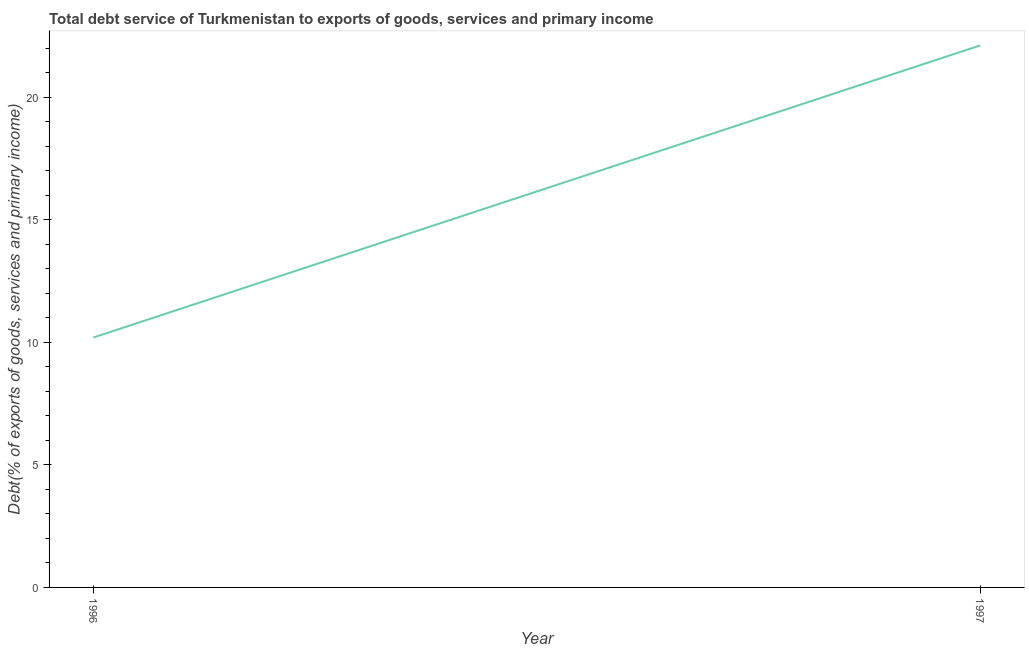What is the total debt service in 1997?
Give a very brief answer. 22.11. Across all years, what is the maximum total debt service?
Provide a succinct answer. 22.11. Across all years, what is the minimum total debt service?
Give a very brief answer. 10.2. In which year was the total debt service maximum?
Keep it short and to the point. 1997. In which year was the total debt service minimum?
Your answer should be compact. 1996. What is the sum of the total debt service?
Give a very brief answer. 32.31. What is the difference between the total debt service in 1996 and 1997?
Ensure brevity in your answer.  -11.92. What is the average total debt service per year?
Make the answer very short. 16.15. What is the median total debt service?
Keep it short and to the point. 16.15. Do a majority of the years between 1996 and 1997 (inclusive) have total debt service greater than 7 %?
Ensure brevity in your answer.  Yes. What is the ratio of the total debt service in 1996 to that in 1997?
Offer a terse response. 0.46. In how many years, is the total debt service greater than the average total debt service taken over all years?
Keep it short and to the point. 1. Does the total debt service monotonically increase over the years?
Offer a very short reply. Yes. How many lines are there?
Offer a very short reply. 1. Are the values on the major ticks of Y-axis written in scientific E-notation?
Ensure brevity in your answer.  No. What is the title of the graph?
Offer a terse response. Total debt service of Turkmenistan to exports of goods, services and primary income. What is the label or title of the Y-axis?
Your answer should be very brief. Debt(% of exports of goods, services and primary income). What is the Debt(% of exports of goods, services and primary income) of 1996?
Offer a very short reply. 10.2. What is the Debt(% of exports of goods, services and primary income) of 1997?
Offer a very short reply. 22.11. What is the difference between the Debt(% of exports of goods, services and primary income) in 1996 and 1997?
Give a very brief answer. -11.92. What is the ratio of the Debt(% of exports of goods, services and primary income) in 1996 to that in 1997?
Your answer should be compact. 0.46. 